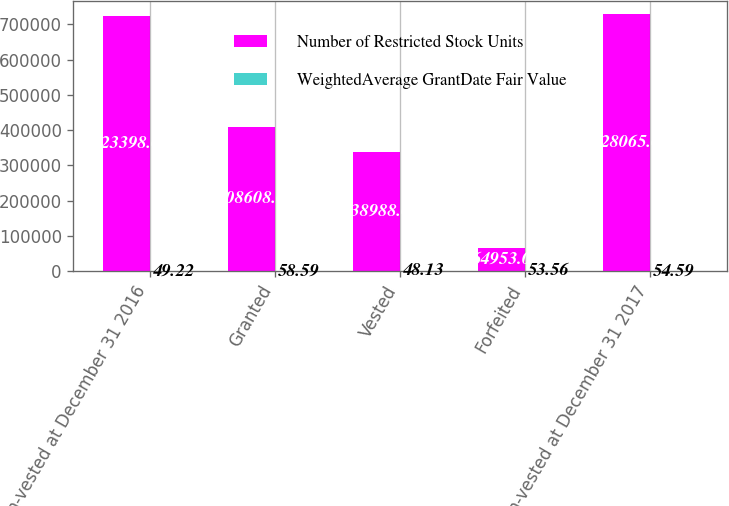<chart> <loc_0><loc_0><loc_500><loc_500><stacked_bar_chart><ecel><fcel>Non-vested at December 31 2016<fcel>Granted<fcel>Vested<fcel>Forfeited<fcel>Non-vested at December 31 2017<nl><fcel>Number of Restricted Stock Units<fcel>723398<fcel>408608<fcel>338988<fcel>64953<fcel>728065<nl><fcel>WeightedAverage GrantDate Fair Value<fcel>49.22<fcel>58.59<fcel>48.13<fcel>53.56<fcel>54.59<nl></chart> 